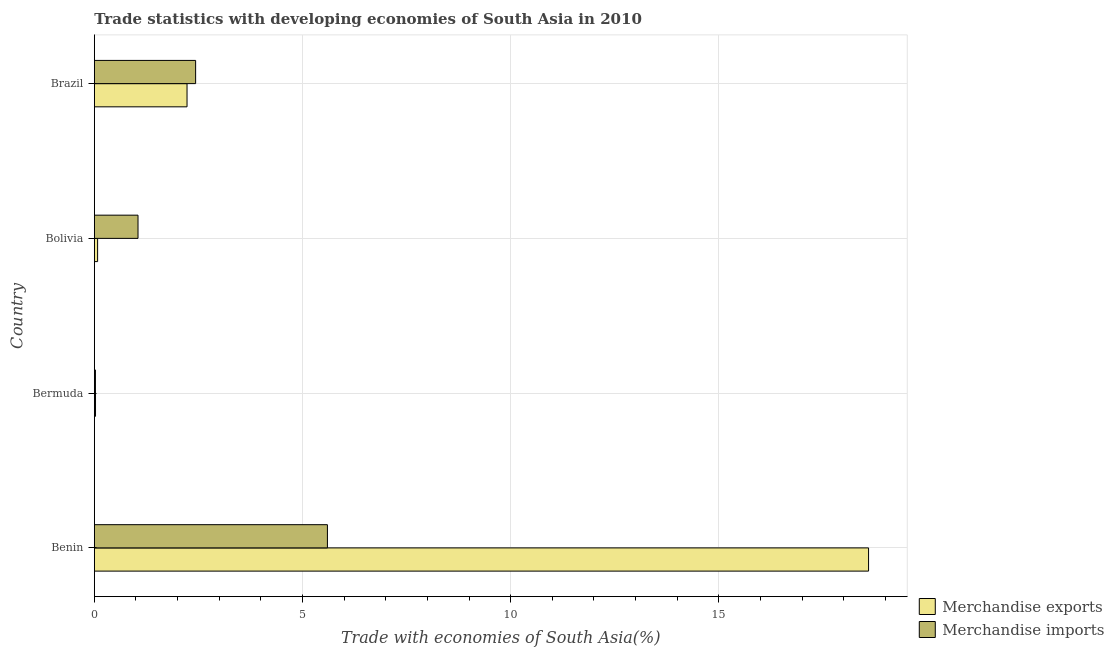How many different coloured bars are there?
Provide a short and direct response. 2. Are the number of bars on each tick of the Y-axis equal?
Provide a short and direct response. Yes. How many bars are there on the 3rd tick from the bottom?
Give a very brief answer. 2. What is the merchandise exports in Bermuda?
Keep it short and to the point. 0.03. Across all countries, what is the maximum merchandise imports?
Your answer should be compact. 5.6. Across all countries, what is the minimum merchandise imports?
Your response must be concise. 0.03. In which country was the merchandise exports maximum?
Your answer should be compact. Benin. In which country was the merchandise exports minimum?
Your answer should be compact. Bermuda. What is the total merchandise imports in the graph?
Your answer should be compact. 9.11. What is the difference between the merchandise exports in Bermuda and that in Brazil?
Provide a short and direct response. -2.2. What is the difference between the merchandise exports in Brazil and the merchandise imports in Bolivia?
Your answer should be very brief. 1.18. What is the average merchandise exports per country?
Offer a very short reply. 5.23. What is the difference between the merchandise exports and merchandise imports in Benin?
Ensure brevity in your answer.  13. What is the ratio of the merchandise exports in Benin to that in Brazil?
Your response must be concise. 8.35. Is the merchandise exports in Benin less than that in Bermuda?
Your response must be concise. No. What is the difference between the highest and the second highest merchandise imports?
Offer a terse response. 3.17. What is the difference between the highest and the lowest merchandise exports?
Make the answer very short. 18.57. In how many countries, is the merchandise imports greater than the average merchandise imports taken over all countries?
Offer a very short reply. 2. Is the sum of the merchandise exports in Benin and Bolivia greater than the maximum merchandise imports across all countries?
Provide a short and direct response. Yes. What does the 1st bar from the top in Brazil represents?
Your response must be concise. Merchandise imports. How many bars are there?
Make the answer very short. 8. How many countries are there in the graph?
Your response must be concise. 4. Where does the legend appear in the graph?
Your answer should be very brief. Bottom right. How many legend labels are there?
Ensure brevity in your answer.  2. What is the title of the graph?
Give a very brief answer. Trade statistics with developing economies of South Asia in 2010. Does "Males" appear as one of the legend labels in the graph?
Your response must be concise. No. What is the label or title of the X-axis?
Your answer should be very brief. Trade with economies of South Asia(%). What is the Trade with economies of South Asia(%) of Merchandise exports in Benin?
Your answer should be very brief. 18.59. What is the Trade with economies of South Asia(%) of Merchandise imports in Benin?
Provide a short and direct response. 5.6. What is the Trade with economies of South Asia(%) in Merchandise exports in Bermuda?
Your response must be concise. 0.03. What is the Trade with economies of South Asia(%) of Merchandise imports in Bermuda?
Offer a very short reply. 0.03. What is the Trade with economies of South Asia(%) in Merchandise exports in Bolivia?
Keep it short and to the point. 0.08. What is the Trade with economies of South Asia(%) in Merchandise imports in Bolivia?
Your answer should be very brief. 1.05. What is the Trade with economies of South Asia(%) in Merchandise exports in Brazil?
Provide a short and direct response. 2.23. What is the Trade with economies of South Asia(%) in Merchandise imports in Brazil?
Make the answer very short. 2.43. Across all countries, what is the maximum Trade with economies of South Asia(%) in Merchandise exports?
Ensure brevity in your answer.  18.59. Across all countries, what is the maximum Trade with economies of South Asia(%) in Merchandise imports?
Your answer should be compact. 5.6. Across all countries, what is the minimum Trade with economies of South Asia(%) in Merchandise exports?
Your answer should be very brief. 0.03. Across all countries, what is the minimum Trade with economies of South Asia(%) of Merchandise imports?
Provide a succinct answer. 0.03. What is the total Trade with economies of South Asia(%) of Merchandise exports in the graph?
Your answer should be very brief. 20.93. What is the total Trade with economies of South Asia(%) of Merchandise imports in the graph?
Your answer should be very brief. 9.11. What is the difference between the Trade with economies of South Asia(%) of Merchandise exports in Benin and that in Bermuda?
Give a very brief answer. 18.57. What is the difference between the Trade with economies of South Asia(%) of Merchandise imports in Benin and that in Bermuda?
Your answer should be very brief. 5.57. What is the difference between the Trade with economies of South Asia(%) in Merchandise exports in Benin and that in Bolivia?
Ensure brevity in your answer.  18.52. What is the difference between the Trade with economies of South Asia(%) in Merchandise imports in Benin and that in Bolivia?
Keep it short and to the point. 4.55. What is the difference between the Trade with economies of South Asia(%) in Merchandise exports in Benin and that in Brazil?
Offer a terse response. 16.37. What is the difference between the Trade with economies of South Asia(%) in Merchandise imports in Benin and that in Brazil?
Keep it short and to the point. 3.17. What is the difference between the Trade with economies of South Asia(%) in Merchandise exports in Bermuda and that in Bolivia?
Provide a succinct answer. -0.05. What is the difference between the Trade with economies of South Asia(%) of Merchandise imports in Bermuda and that in Bolivia?
Ensure brevity in your answer.  -1.02. What is the difference between the Trade with economies of South Asia(%) of Merchandise exports in Bermuda and that in Brazil?
Offer a terse response. -2.2. What is the difference between the Trade with economies of South Asia(%) of Merchandise imports in Bermuda and that in Brazil?
Offer a very short reply. -2.41. What is the difference between the Trade with economies of South Asia(%) in Merchandise exports in Bolivia and that in Brazil?
Your answer should be very brief. -2.15. What is the difference between the Trade with economies of South Asia(%) in Merchandise imports in Bolivia and that in Brazil?
Offer a very short reply. -1.38. What is the difference between the Trade with economies of South Asia(%) in Merchandise exports in Benin and the Trade with economies of South Asia(%) in Merchandise imports in Bermuda?
Give a very brief answer. 18.57. What is the difference between the Trade with economies of South Asia(%) of Merchandise exports in Benin and the Trade with economies of South Asia(%) of Merchandise imports in Bolivia?
Offer a terse response. 17.55. What is the difference between the Trade with economies of South Asia(%) in Merchandise exports in Benin and the Trade with economies of South Asia(%) in Merchandise imports in Brazil?
Provide a short and direct response. 16.16. What is the difference between the Trade with economies of South Asia(%) in Merchandise exports in Bermuda and the Trade with economies of South Asia(%) in Merchandise imports in Bolivia?
Offer a very short reply. -1.02. What is the difference between the Trade with economies of South Asia(%) of Merchandise exports in Bermuda and the Trade with economies of South Asia(%) of Merchandise imports in Brazil?
Provide a succinct answer. -2.4. What is the difference between the Trade with economies of South Asia(%) in Merchandise exports in Bolivia and the Trade with economies of South Asia(%) in Merchandise imports in Brazil?
Your answer should be compact. -2.35. What is the average Trade with economies of South Asia(%) of Merchandise exports per country?
Keep it short and to the point. 5.23. What is the average Trade with economies of South Asia(%) of Merchandise imports per country?
Keep it short and to the point. 2.28. What is the difference between the Trade with economies of South Asia(%) in Merchandise exports and Trade with economies of South Asia(%) in Merchandise imports in Benin?
Keep it short and to the point. 13. What is the difference between the Trade with economies of South Asia(%) in Merchandise exports and Trade with economies of South Asia(%) in Merchandise imports in Bermuda?
Offer a terse response. 0. What is the difference between the Trade with economies of South Asia(%) in Merchandise exports and Trade with economies of South Asia(%) in Merchandise imports in Bolivia?
Ensure brevity in your answer.  -0.97. What is the difference between the Trade with economies of South Asia(%) of Merchandise exports and Trade with economies of South Asia(%) of Merchandise imports in Brazil?
Keep it short and to the point. -0.21. What is the ratio of the Trade with economies of South Asia(%) in Merchandise exports in Benin to that in Bermuda?
Give a very brief answer. 660.88. What is the ratio of the Trade with economies of South Asia(%) in Merchandise imports in Benin to that in Bermuda?
Your response must be concise. 210.4. What is the ratio of the Trade with economies of South Asia(%) in Merchandise exports in Benin to that in Bolivia?
Your answer should be compact. 236.66. What is the ratio of the Trade with economies of South Asia(%) in Merchandise imports in Benin to that in Bolivia?
Give a very brief answer. 5.34. What is the ratio of the Trade with economies of South Asia(%) in Merchandise exports in Benin to that in Brazil?
Keep it short and to the point. 8.35. What is the ratio of the Trade with economies of South Asia(%) in Merchandise imports in Benin to that in Brazil?
Make the answer very short. 2.3. What is the ratio of the Trade with economies of South Asia(%) in Merchandise exports in Bermuda to that in Bolivia?
Your answer should be very brief. 0.36. What is the ratio of the Trade with economies of South Asia(%) in Merchandise imports in Bermuda to that in Bolivia?
Your response must be concise. 0.03. What is the ratio of the Trade with economies of South Asia(%) of Merchandise exports in Bermuda to that in Brazil?
Make the answer very short. 0.01. What is the ratio of the Trade with economies of South Asia(%) in Merchandise imports in Bermuda to that in Brazil?
Provide a succinct answer. 0.01. What is the ratio of the Trade with economies of South Asia(%) in Merchandise exports in Bolivia to that in Brazil?
Offer a very short reply. 0.04. What is the ratio of the Trade with economies of South Asia(%) of Merchandise imports in Bolivia to that in Brazil?
Offer a very short reply. 0.43. What is the difference between the highest and the second highest Trade with economies of South Asia(%) of Merchandise exports?
Offer a very short reply. 16.37. What is the difference between the highest and the second highest Trade with economies of South Asia(%) in Merchandise imports?
Provide a short and direct response. 3.17. What is the difference between the highest and the lowest Trade with economies of South Asia(%) of Merchandise exports?
Provide a short and direct response. 18.57. What is the difference between the highest and the lowest Trade with economies of South Asia(%) of Merchandise imports?
Keep it short and to the point. 5.57. 